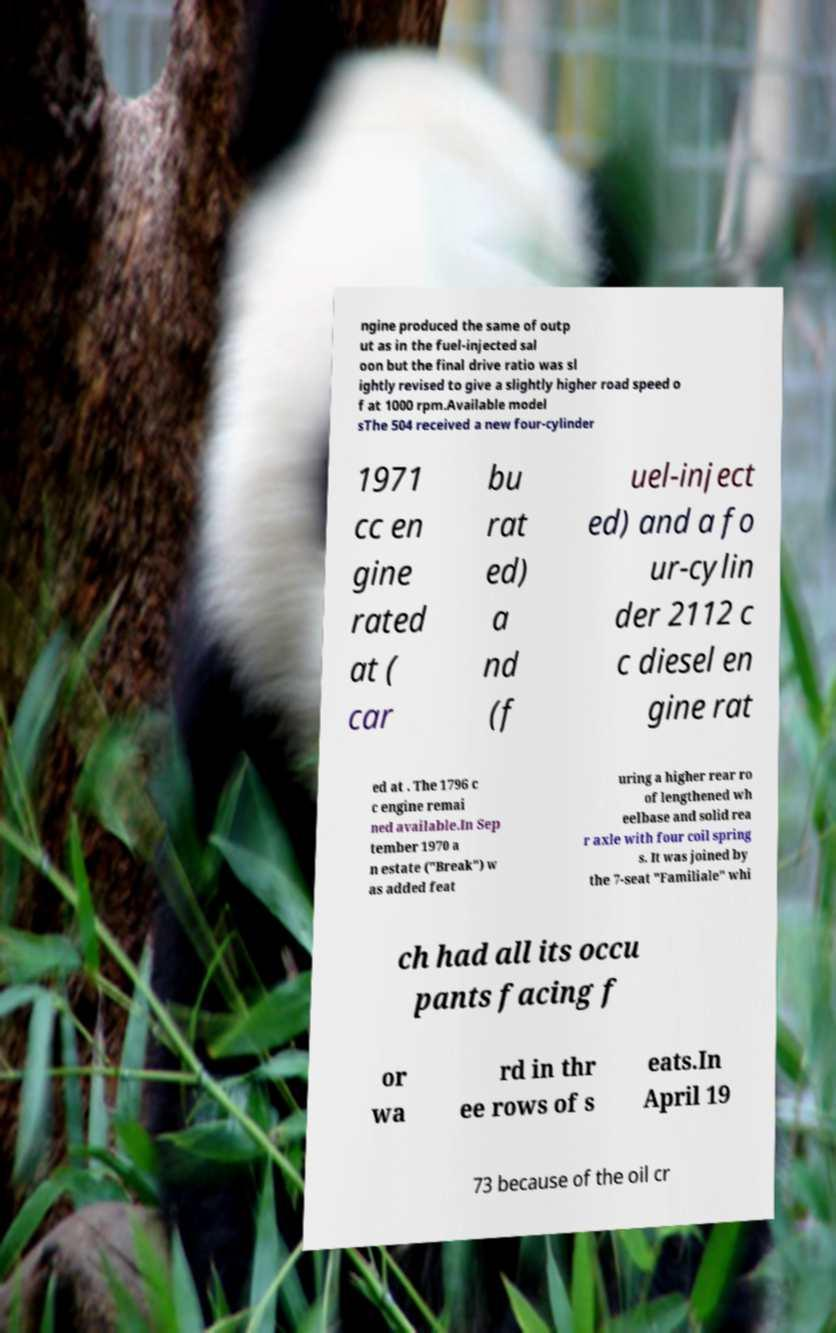Could you extract and type out the text from this image? ngine produced the same of outp ut as in the fuel-injected sal oon but the final drive ratio was sl ightly revised to give a slightly higher road speed o f at 1000 rpm.Available model sThe 504 received a new four-cylinder 1971 cc en gine rated at ( car bu rat ed) a nd (f uel-inject ed) and a fo ur-cylin der 2112 c c diesel en gine rat ed at . The 1796 c c engine remai ned available.In Sep tember 1970 a n estate ("Break") w as added feat uring a higher rear ro of lengthened wh eelbase and solid rea r axle with four coil spring s. It was joined by the 7-seat "Familiale" whi ch had all its occu pants facing f or wa rd in thr ee rows of s eats.In April 19 73 because of the oil cr 